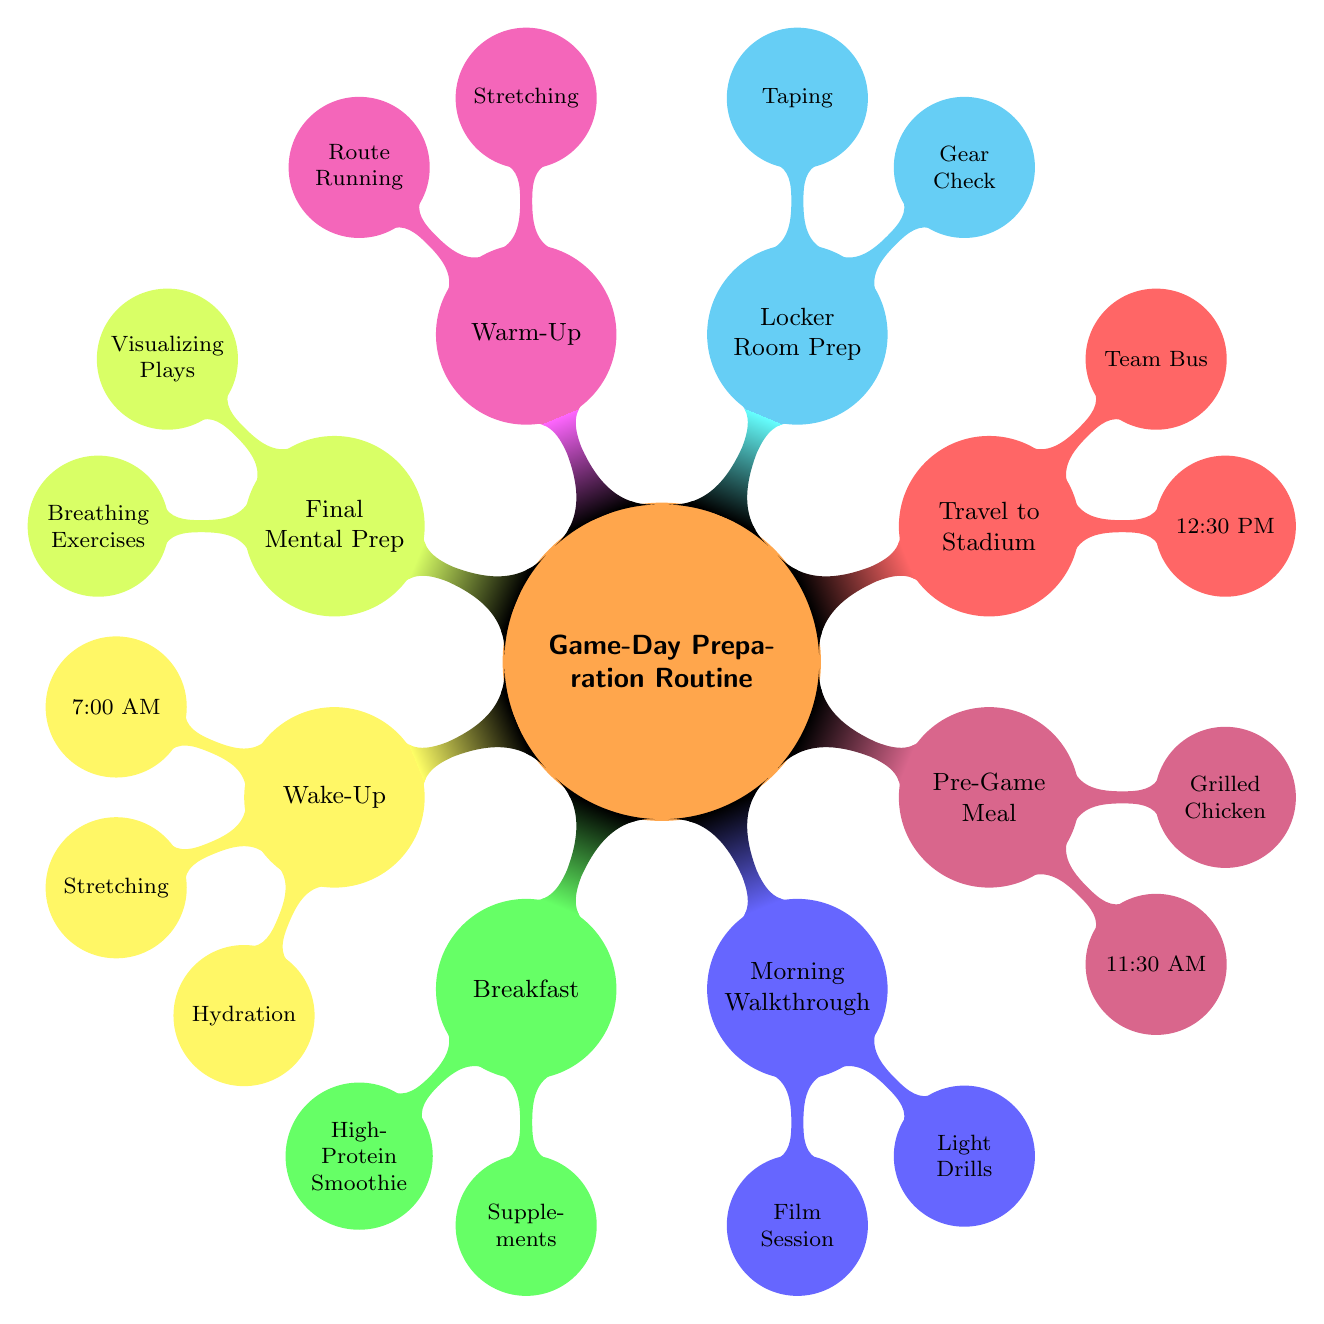What time do you wake up on game day? The diagram clearly states that the wake-up time is 7:00 AM, which is indicated in the node under "Wake-Up".
Answer: 7:00 AM What meal is consumed for breakfast? The "Breakfast" node shows that the meal is a "High-Protein Smoothie," which is detailed within that section.
Answer: High-Protein Smoothie What activity occurs just before kick-off? The final preparation before kick-off includes "Visualizing Plays" and "Breathing Exercises," as highlighted and designated in the "Final Mental Prep" node.
Answer: Visualizing Plays What time is the pre-game meal served? The node labeled "Pre-Game Meal" specifies that it is served at 11:30 AM. This detail is explicitly listed within that section.
Answer: 11:30 AM Which transportation mode is used to travel to the stadium? According to the "Travel to Stadium" node, the designated mode of transportation is the "Team Bus," which is clearly stated there.
Answer: Team Bus How many activities are listed under Locker Room Preparation? The "Locker Room Preparation" node mentions three activities: "Gear Check," "Taping and Wrapping," and "Motivational Talk with Quarterback." Therefore, the total number of activities is three.
Answer: 3 Which activities occur during the warm-up? In the "Warm-Up" node, the activities listed are "Stretching" and "Route Running with Quarterback." Both activities are specified in this section.
Answer: Stretching, Route Running What is one of the activities performed during the morning walkthrough? The diagram indicates that "Film Session with Quarterback" is one of the activities under "Morning Walkthrough," as noted in that section.
Answer: Film Session with Quarterback 